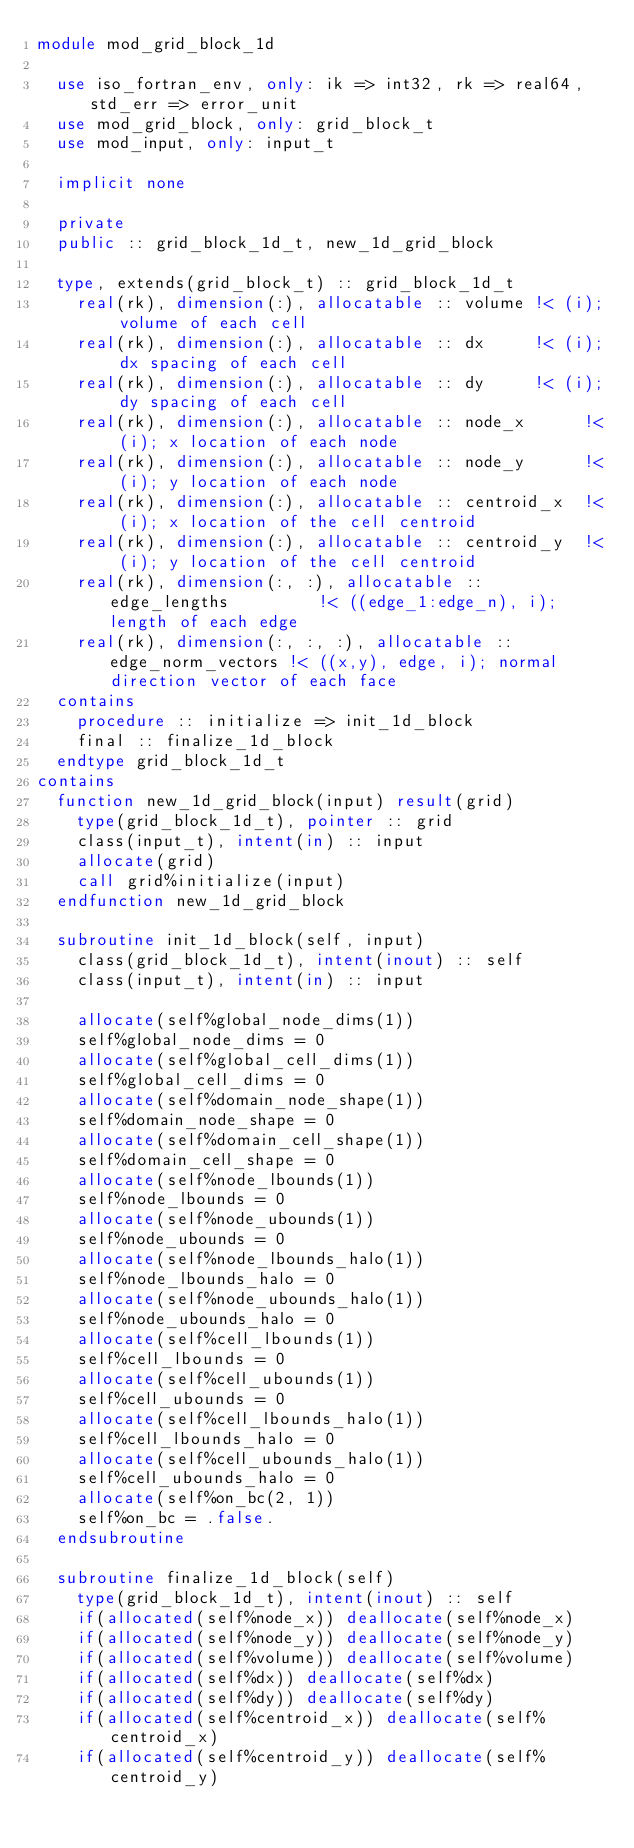<code> <loc_0><loc_0><loc_500><loc_500><_FORTRAN_>module mod_grid_block_1d

  use iso_fortran_env, only: ik => int32, rk => real64, std_err => error_unit
  use mod_grid_block, only: grid_block_t
  use mod_input, only: input_t

  implicit none

  private
  public :: grid_block_1d_t, new_1d_grid_block

  type, extends(grid_block_t) :: grid_block_1d_t
    real(rk), dimension(:), allocatable :: volume !< (i); volume of each cell
    real(rk), dimension(:), allocatable :: dx     !< (i); dx spacing of each cell
    real(rk), dimension(:), allocatable :: dy     !< (i); dy spacing of each cell
    real(rk), dimension(:), allocatable :: node_x      !< (i); x location of each node
    real(rk), dimension(:), allocatable :: node_y      !< (i); y location of each node
    real(rk), dimension(:), allocatable :: centroid_x  !< (i); x location of the cell centroid
    real(rk), dimension(:), allocatable :: centroid_y  !< (i); y location of the cell centroid
    real(rk), dimension(:, :), allocatable :: edge_lengths         !< ((edge_1:edge_n), i); length of each edge
    real(rk), dimension(:, :, :), allocatable :: edge_norm_vectors !< ((x,y), edge, i); normal direction vector of each face
  contains
    procedure :: initialize => init_1d_block
    final :: finalize_1d_block
  endtype grid_block_1d_t
contains
  function new_1d_grid_block(input) result(grid)
    type(grid_block_1d_t), pointer :: grid
    class(input_t), intent(in) :: input
    allocate(grid)
    call grid%initialize(input)
  endfunction new_1d_grid_block

  subroutine init_1d_block(self, input)
    class(grid_block_1d_t), intent(inout) :: self
    class(input_t), intent(in) :: input

    allocate(self%global_node_dims(1))
    self%global_node_dims = 0
    allocate(self%global_cell_dims(1))
    self%global_cell_dims = 0
    allocate(self%domain_node_shape(1))
    self%domain_node_shape = 0
    allocate(self%domain_cell_shape(1))
    self%domain_cell_shape = 0
    allocate(self%node_lbounds(1))
    self%node_lbounds = 0
    allocate(self%node_ubounds(1))
    self%node_ubounds = 0
    allocate(self%node_lbounds_halo(1))
    self%node_lbounds_halo = 0
    allocate(self%node_ubounds_halo(1))
    self%node_ubounds_halo = 0
    allocate(self%cell_lbounds(1))
    self%cell_lbounds = 0
    allocate(self%cell_ubounds(1))
    self%cell_ubounds = 0
    allocate(self%cell_lbounds_halo(1))
    self%cell_lbounds_halo = 0
    allocate(self%cell_ubounds_halo(1))
    self%cell_ubounds_halo = 0
    allocate(self%on_bc(2, 1))
    self%on_bc = .false.
  endsubroutine

  subroutine finalize_1d_block(self)
    type(grid_block_1d_t), intent(inout) :: self
    if(allocated(self%node_x)) deallocate(self%node_x)
    if(allocated(self%node_y)) deallocate(self%node_y)
    if(allocated(self%volume)) deallocate(self%volume)
    if(allocated(self%dx)) deallocate(self%dx)
    if(allocated(self%dy)) deallocate(self%dy)
    if(allocated(self%centroid_x)) deallocate(self%centroid_x)
    if(allocated(self%centroid_y)) deallocate(self%centroid_y)</code> 